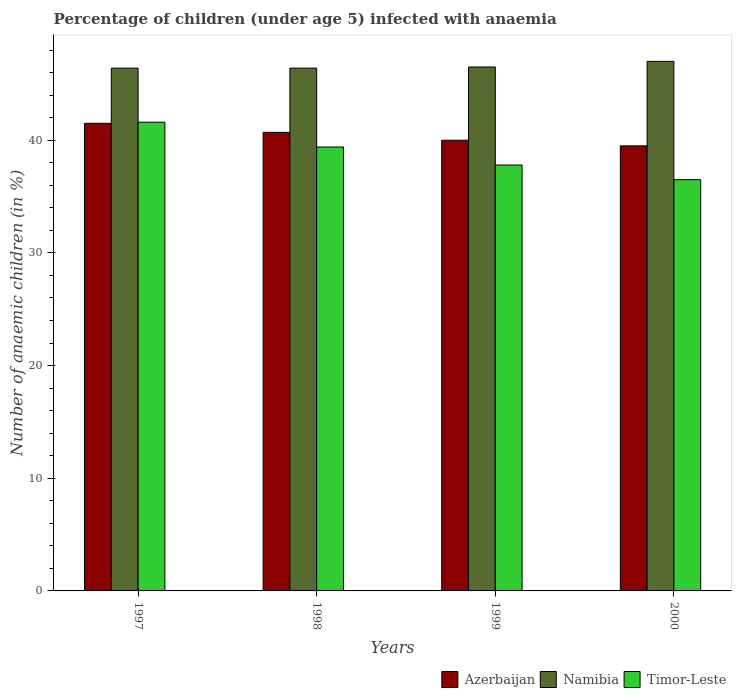How many different coloured bars are there?
Make the answer very short. 3. How many groups of bars are there?
Your response must be concise. 4. How many bars are there on the 3rd tick from the left?
Ensure brevity in your answer.  3. In how many cases, is the number of bars for a given year not equal to the number of legend labels?
Provide a succinct answer. 0. What is the percentage of children infected with anaemia in in Timor-Leste in 1999?
Provide a succinct answer. 37.8. Across all years, what is the maximum percentage of children infected with anaemia in in Azerbaijan?
Keep it short and to the point. 41.5. Across all years, what is the minimum percentage of children infected with anaemia in in Namibia?
Offer a very short reply. 46.4. In which year was the percentage of children infected with anaemia in in Azerbaijan minimum?
Give a very brief answer. 2000. What is the total percentage of children infected with anaemia in in Namibia in the graph?
Make the answer very short. 186.3. What is the difference between the percentage of children infected with anaemia in in Timor-Leste in 1997 and that in 1999?
Ensure brevity in your answer.  3.8. What is the difference between the percentage of children infected with anaemia in in Timor-Leste in 1998 and the percentage of children infected with anaemia in in Azerbaijan in 1999?
Provide a short and direct response. -0.6. What is the average percentage of children infected with anaemia in in Azerbaijan per year?
Provide a succinct answer. 40.42. In the year 1999, what is the difference between the percentage of children infected with anaemia in in Timor-Leste and percentage of children infected with anaemia in in Namibia?
Your answer should be compact. -8.7. In how many years, is the percentage of children infected with anaemia in in Namibia greater than 22 %?
Offer a terse response. 4. What is the ratio of the percentage of children infected with anaemia in in Timor-Leste in 1999 to that in 2000?
Your answer should be compact. 1.04. What is the difference between the highest and the lowest percentage of children infected with anaemia in in Azerbaijan?
Give a very brief answer. 2. In how many years, is the percentage of children infected with anaemia in in Azerbaijan greater than the average percentage of children infected with anaemia in in Azerbaijan taken over all years?
Offer a terse response. 2. What does the 3rd bar from the left in 1998 represents?
Make the answer very short. Timor-Leste. What does the 3rd bar from the right in 1998 represents?
Ensure brevity in your answer.  Azerbaijan. Is it the case that in every year, the sum of the percentage of children infected with anaemia in in Timor-Leste and percentage of children infected with anaemia in in Azerbaijan is greater than the percentage of children infected with anaemia in in Namibia?
Offer a very short reply. Yes. How many years are there in the graph?
Ensure brevity in your answer.  4. What is the difference between two consecutive major ticks on the Y-axis?
Offer a very short reply. 10. Does the graph contain grids?
Offer a very short reply. No. Where does the legend appear in the graph?
Your response must be concise. Bottom right. What is the title of the graph?
Give a very brief answer. Percentage of children (under age 5) infected with anaemia. What is the label or title of the X-axis?
Give a very brief answer. Years. What is the label or title of the Y-axis?
Keep it short and to the point. Number of anaemic children (in %). What is the Number of anaemic children (in %) of Azerbaijan in 1997?
Your response must be concise. 41.5. What is the Number of anaemic children (in %) in Namibia in 1997?
Give a very brief answer. 46.4. What is the Number of anaemic children (in %) of Timor-Leste in 1997?
Offer a very short reply. 41.6. What is the Number of anaemic children (in %) of Azerbaijan in 1998?
Offer a terse response. 40.7. What is the Number of anaemic children (in %) of Namibia in 1998?
Provide a succinct answer. 46.4. What is the Number of anaemic children (in %) in Timor-Leste in 1998?
Your answer should be very brief. 39.4. What is the Number of anaemic children (in %) in Namibia in 1999?
Provide a succinct answer. 46.5. What is the Number of anaemic children (in %) of Timor-Leste in 1999?
Offer a very short reply. 37.8. What is the Number of anaemic children (in %) of Azerbaijan in 2000?
Keep it short and to the point. 39.5. What is the Number of anaemic children (in %) in Namibia in 2000?
Make the answer very short. 47. What is the Number of anaemic children (in %) in Timor-Leste in 2000?
Provide a succinct answer. 36.5. Across all years, what is the maximum Number of anaemic children (in %) of Azerbaijan?
Your answer should be compact. 41.5. Across all years, what is the maximum Number of anaemic children (in %) in Namibia?
Provide a succinct answer. 47. Across all years, what is the maximum Number of anaemic children (in %) in Timor-Leste?
Offer a very short reply. 41.6. Across all years, what is the minimum Number of anaemic children (in %) in Azerbaijan?
Your response must be concise. 39.5. Across all years, what is the minimum Number of anaemic children (in %) in Namibia?
Give a very brief answer. 46.4. Across all years, what is the minimum Number of anaemic children (in %) of Timor-Leste?
Offer a terse response. 36.5. What is the total Number of anaemic children (in %) of Azerbaijan in the graph?
Keep it short and to the point. 161.7. What is the total Number of anaemic children (in %) of Namibia in the graph?
Your answer should be very brief. 186.3. What is the total Number of anaemic children (in %) of Timor-Leste in the graph?
Your response must be concise. 155.3. What is the difference between the Number of anaemic children (in %) in Azerbaijan in 1997 and that in 1998?
Keep it short and to the point. 0.8. What is the difference between the Number of anaemic children (in %) of Namibia in 1997 and that in 1998?
Provide a short and direct response. 0. What is the difference between the Number of anaemic children (in %) in Timor-Leste in 1997 and that in 1998?
Your response must be concise. 2.2. What is the difference between the Number of anaemic children (in %) of Timor-Leste in 1997 and that in 1999?
Your answer should be compact. 3.8. What is the difference between the Number of anaemic children (in %) of Azerbaijan in 1997 and that in 2000?
Give a very brief answer. 2. What is the difference between the Number of anaemic children (in %) of Timor-Leste in 1997 and that in 2000?
Keep it short and to the point. 5.1. What is the difference between the Number of anaemic children (in %) of Namibia in 1998 and that in 1999?
Make the answer very short. -0.1. What is the difference between the Number of anaemic children (in %) of Timor-Leste in 1998 and that in 1999?
Your answer should be very brief. 1.6. What is the difference between the Number of anaemic children (in %) in Timor-Leste in 1998 and that in 2000?
Your response must be concise. 2.9. What is the difference between the Number of anaemic children (in %) in Azerbaijan in 1999 and that in 2000?
Your answer should be compact. 0.5. What is the difference between the Number of anaemic children (in %) in Namibia in 1999 and that in 2000?
Keep it short and to the point. -0.5. What is the difference between the Number of anaemic children (in %) in Azerbaijan in 1997 and the Number of anaemic children (in %) in Namibia in 1998?
Make the answer very short. -4.9. What is the difference between the Number of anaemic children (in %) in Namibia in 1997 and the Number of anaemic children (in %) in Timor-Leste in 1998?
Your answer should be very brief. 7. What is the difference between the Number of anaemic children (in %) of Azerbaijan in 1997 and the Number of anaemic children (in %) of Timor-Leste in 1999?
Your response must be concise. 3.7. What is the difference between the Number of anaemic children (in %) of Namibia in 1997 and the Number of anaemic children (in %) of Timor-Leste in 1999?
Provide a short and direct response. 8.6. What is the difference between the Number of anaemic children (in %) in Azerbaijan in 1997 and the Number of anaemic children (in %) in Timor-Leste in 2000?
Keep it short and to the point. 5. What is the difference between the Number of anaemic children (in %) of Azerbaijan in 1998 and the Number of anaemic children (in %) of Namibia in 1999?
Your answer should be compact. -5.8. What is the difference between the Number of anaemic children (in %) of Azerbaijan in 1998 and the Number of anaemic children (in %) of Timor-Leste in 1999?
Ensure brevity in your answer.  2.9. What is the difference between the Number of anaemic children (in %) in Azerbaijan in 1998 and the Number of anaemic children (in %) in Namibia in 2000?
Ensure brevity in your answer.  -6.3. What is the difference between the Number of anaemic children (in %) of Azerbaijan in 1998 and the Number of anaemic children (in %) of Timor-Leste in 2000?
Offer a very short reply. 4.2. What is the difference between the Number of anaemic children (in %) of Namibia in 1998 and the Number of anaemic children (in %) of Timor-Leste in 2000?
Make the answer very short. 9.9. What is the average Number of anaemic children (in %) of Azerbaijan per year?
Provide a succinct answer. 40.42. What is the average Number of anaemic children (in %) of Namibia per year?
Make the answer very short. 46.58. What is the average Number of anaemic children (in %) of Timor-Leste per year?
Ensure brevity in your answer.  38.83. In the year 1997, what is the difference between the Number of anaemic children (in %) of Azerbaijan and Number of anaemic children (in %) of Namibia?
Keep it short and to the point. -4.9. In the year 2000, what is the difference between the Number of anaemic children (in %) of Azerbaijan and Number of anaemic children (in %) of Timor-Leste?
Your answer should be compact. 3. What is the ratio of the Number of anaemic children (in %) of Azerbaijan in 1997 to that in 1998?
Provide a short and direct response. 1.02. What is the ratio of the Number of anaemic children (in %) in Timor-Leste in 1997 to that in 1998?
Your response must be concise. 1.06. What is the ratio of the Number of anaemic children (in %) of Azerbaijan in 1997 to that in 1999?
Your answer should be very brief. 1.04. What is the ratio of the Number of anaemic children (in %) in Namibia in 1997 to that in 1999?
Provide a succinct answer. 1. What is the ratio of the Number of anaemic children (in %) in Timor-Leste in 1997 to that in 1999?
Give a very brief answer. 1.1. What is the ratio of the Number of anaemic children (in %) of Azerbaijan in 1997 to that in 2000?
Your answer should be very brief. 1.05. What is the ratio of the Number of anaemic children (in %) of Namibia in 1997 to that in 2000?
Provide a succinct answer. 0.99. What is the ratio of the Number of anaemic children (in %) of Timor-Leste in 1997 to that in 2000?
Provide a succinct answer. 1.14. What is the ratio of the Number of anaemic children (in %) of Azerbaijan in 1998 to that in 1999?
Offer a terse response. 1.02. What is the ratio of the Number of anaemic children (in %) in Timor-Leste in 1998 to that in 1999?
Offer a very short reply. 1.04. What is the ratio of the Number of anaemic children (in %) in Azerbaijan in 1998 to that in 2000?
Offer a terse response. 1.03. What is the ratio of the Number of anaemic children (in %) of Namibia in 1998 to that in 2000?
Make the answer very short. 0.99. What is the ratio of the Number of anaemic children (in %) in Timor-Leste in 1998 to that in 2000?
Your response must be concise. 1.08. What is the ratio of the Number of anaemic children (in %) of Azerbaijan in 1999 to that in 2000?
Offer a terse response. 1.01. What is the ratio of the Number of anaemic children (in %) of Timor-Leste in 1999 to that in 2000?
Offer a terse response. 1.04. What is the difference between the highest and the second highest Number of anaemic children (in %) of Namibia?
Provide a short and direct response. 0.5. What is the difference between the highest and the lowest Number of anaemic children (in %) in Timor-Leste?
Make the answer very short. 5.1. 